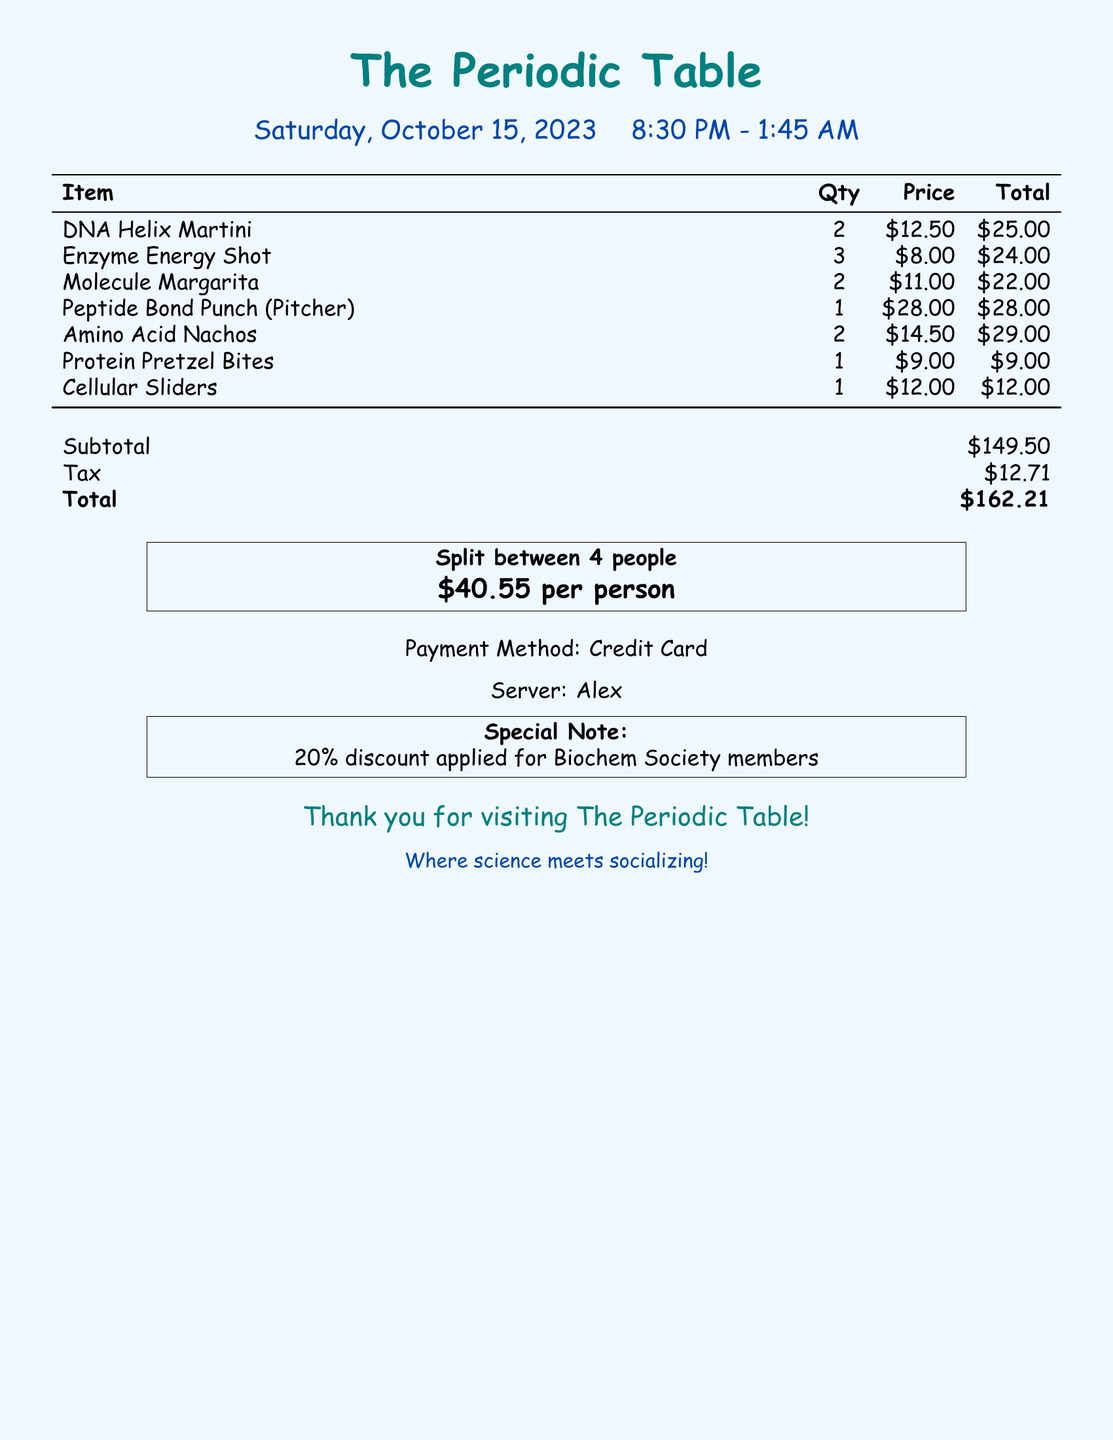What time did the outing start? The outing started at 8:30 PM, as indicated in the document.
Answer: 8:30 PM Who was the server? The server's name is mentioned in the document, revealing the person who served during the outing.
Answer: Alex What was the total amount after tax? The total amount is listed at the end of the document after adding tax to the subtotal.
Answer: $162.21 How many drinks were ordered in total? The total number of drinks can be calculated by summing the quantities listed in the drink section of the document.
Answer: 8 What discount was applied? The special note at the bottom mentions a specific discount for members, which is relevant to the total cost.
Answer: 20% What is the price of the Amino Acid Nachos? The document provides a specific price for this item, which indicates what was charged.
Answer: $14.50 How many people is the total split between? The document explicitly mentions how many people the total bill is split among, providing clarity on cost per person.
Answer: 4 What items were consumed in the outing? The list of items consumed, including drinks and snacks, is clearly laid out in the bill, detailing what was ordered.
Answer: DNA Helix Martini, Enzyme Energy Shot, Molecule Margarita, Peptide Bond Punch, Amino Acid Nachos, Protein Pretzel Bites, Cellular Sliders 